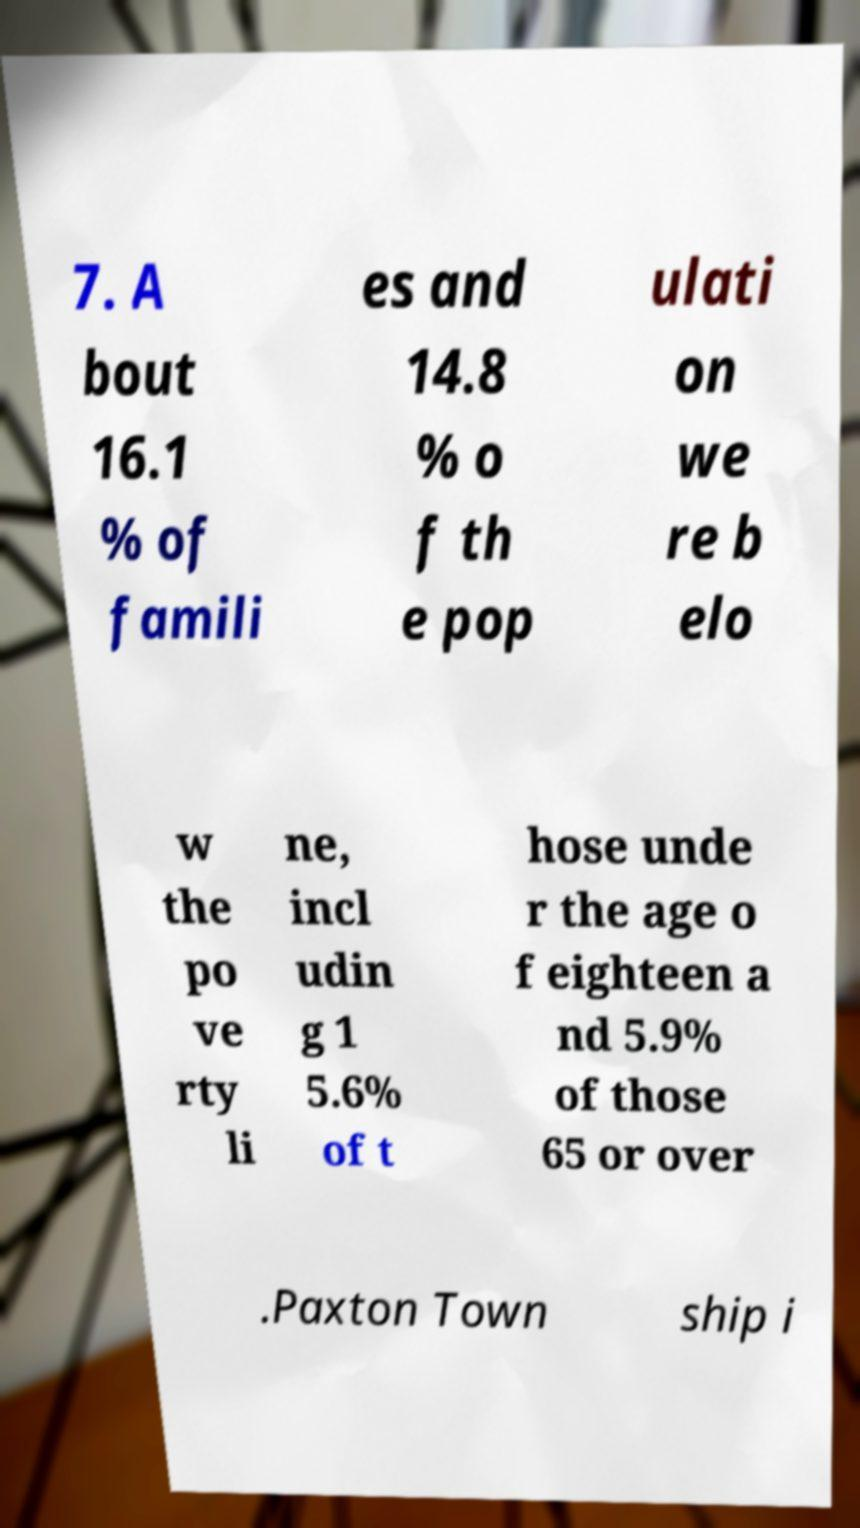Could you extract and type out the text from this image? 7. A bout 16.1 % of famili es and 14.8 % o f th e pop ulati on we re b elo w the po ve rty li ne, incl udin g 1 5.6% of t hose unde r the age o f eighteen a nd 5.9% of those 65 or over .Paxton Town ship i 